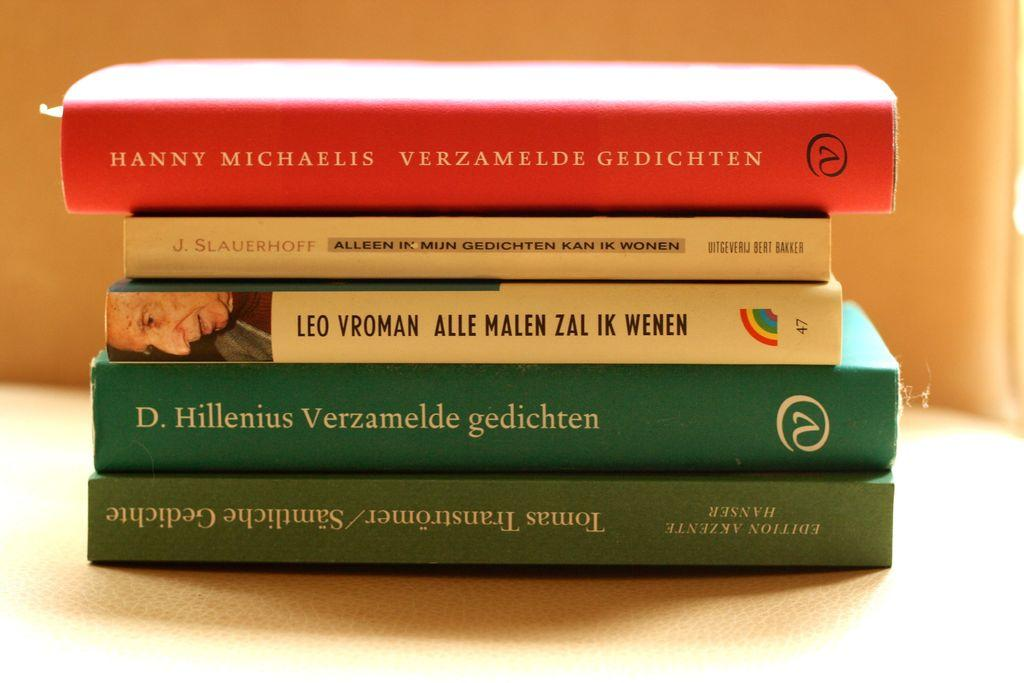<image>
Give a short and clear explanation of the subsequent image. A stack of books are by authors such as Leo Vroman, Hanny Michaelis and D. Hillenius. 